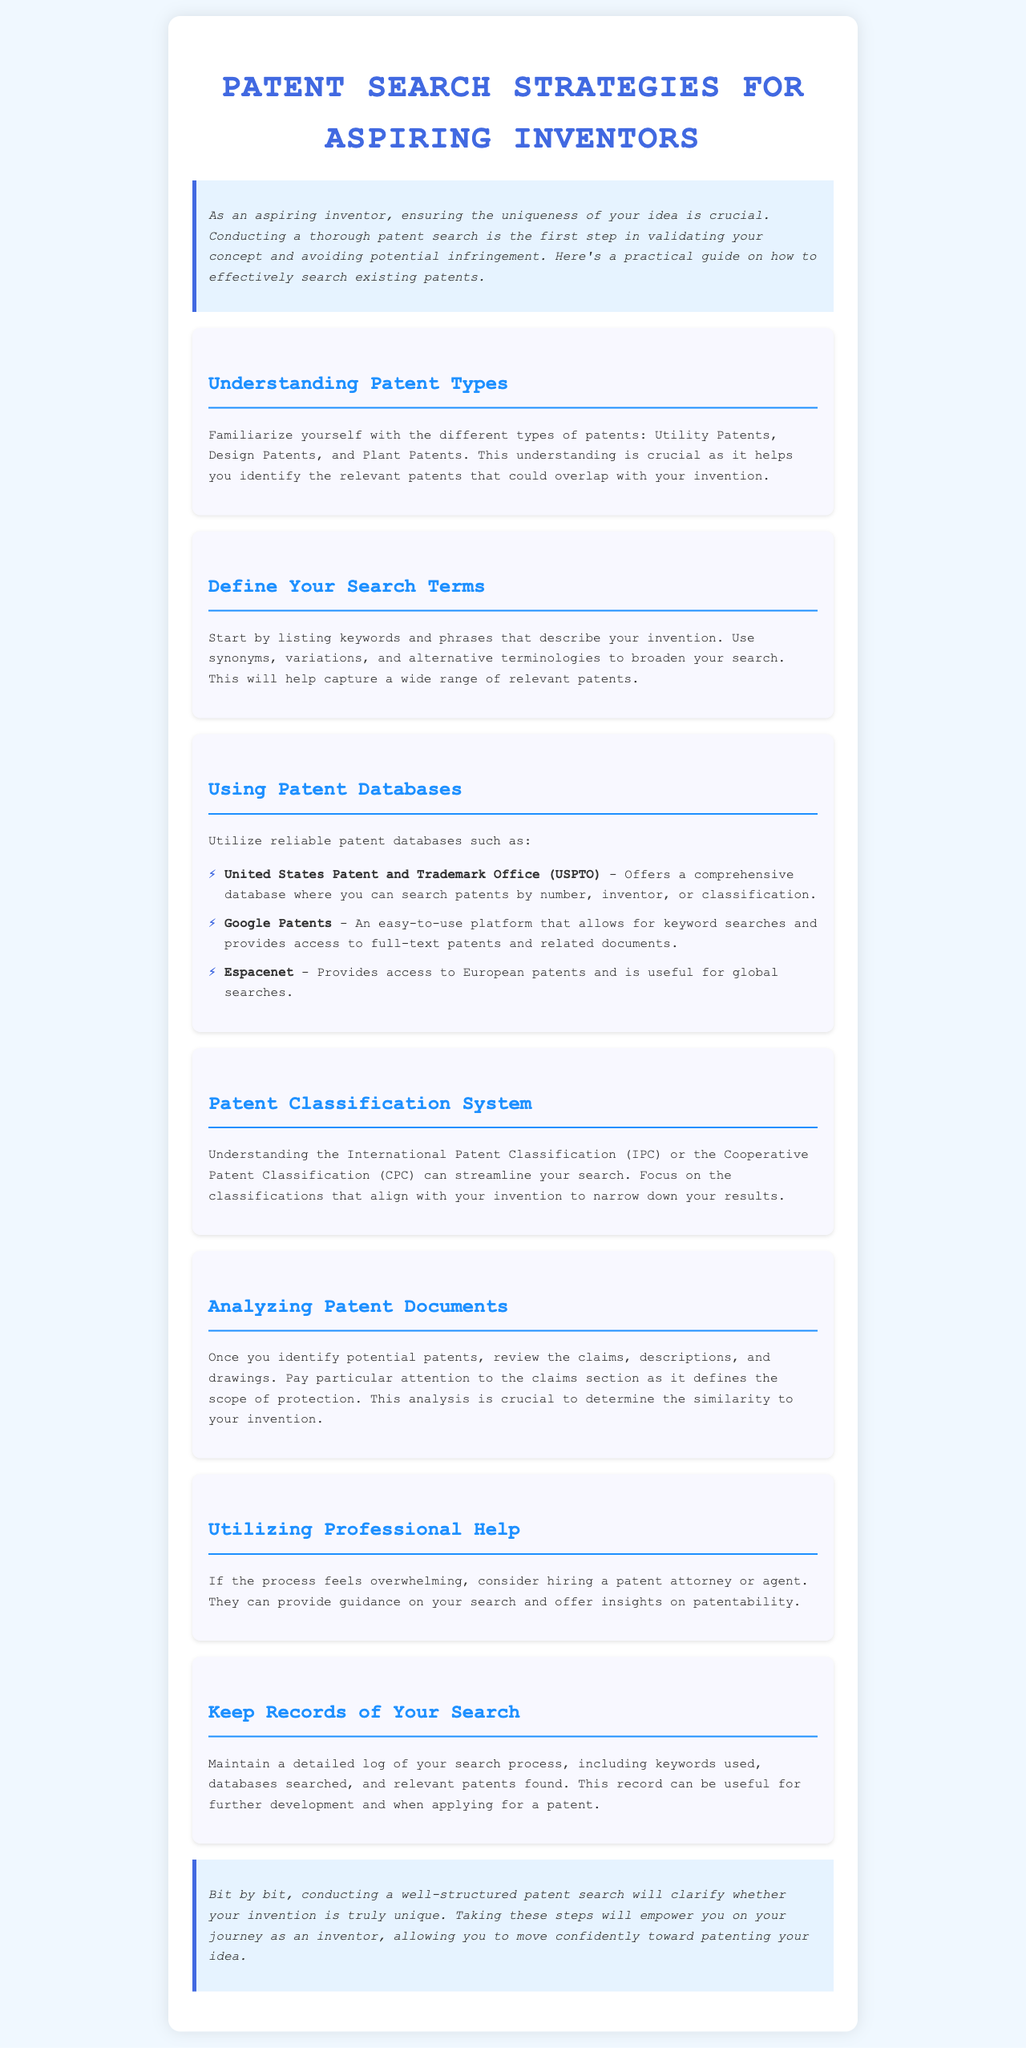What are the different types of patents? The document lists Utility Patents, Design Patents, and Plant Patents as the different types of patents.
Answer: Utility Patents, Design Patents, Plant Patents Which database is described as providing access to European patents? The document mentions Espacenet as the database for accessing European patents.
Answer: Espacenet What should you maintain after conducting a patent search? The document states that you should keep a detailed log of your search process.
Answer: Detailed log What type of professional can assist if the patent search process is overwhelming? The document suggests hiring a patent attorney or agent for assistance.
Answer: Patent attorney or agent What is a critical part of a patent document that defines the scope of protection? The document indicates that the claims section defines the scope of protection.
Answer: Claims section What are some ways to broaden your patent search? The document advises using synonyms, variations, and alternative terminologies to broaden your search.
Answer: Synonyms, variations, alternative terminologies Which patent database is described as easy to use and allows for keyword searches? The document refers to Google Patents as an easy-to-use platform for keyword searches.
Answer: Google Patents What is the first step in validating your invention, according to the document? The document states that conducting a thorough patent search is the first step in validating your concept.
Answer: Conducting a thorough patent search 